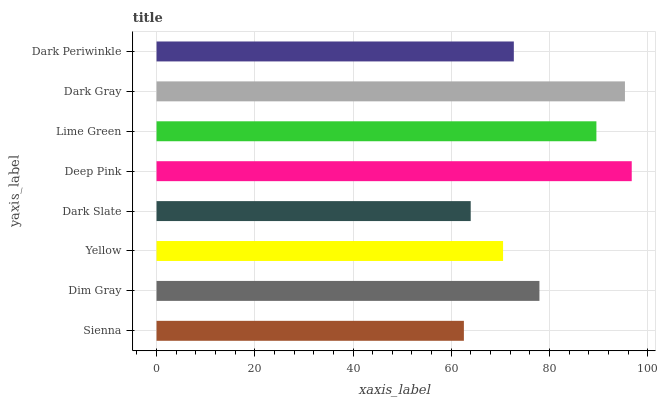Is Sienna the minimum?
Answer yes or no. Yes. Is Deep Pink the maximum?
Answer yes or no. Yes. Is Dim Gray the minimum?
Answer yes or no. No. Is Dim Gray the maximum?
Answer yes or no. No. Is Dim Gray greater than Sienna?
Answer yes or no. Yes. Is Sienna less than Dim Gray?
Answer yes or no. Yes. Is Sienna greater than Dim Gray?
Answer yes or no. No. Is Dim Gray less than Sienna?
Answer yes or no. No. Is Dim Gray the high median?
Answer yes or no. Yes. Is Dark Periwinkle the low median?
Answer yes or no. Yes. Is Dark Periwinkle the high median?
Answer yes or no. No. Is Dark Slate the low median?
Answer yes or no. No. 